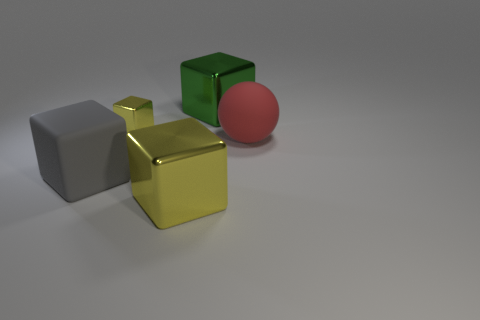Subtract all cyan blocks. Subtract all yellow cylinders. How many blocks are left? 4 Add 1 large spheres. How many objects exist? 6 Add 1 red matte balls. How many red matte balls exist? 2 Subtract 0 gray cylinders. How many objects are left? 5 Subtract all balls. How many objects are left? 4 Subtract all metallic cubes. Subtract all tiny things. How many objects are left? 1 Add 3 large yellow metal cubes. How many large yellow metal cubes are left? 4 